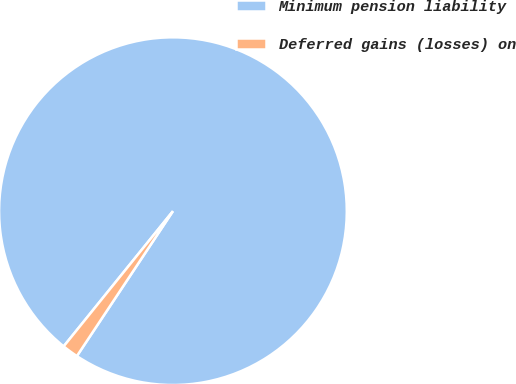Convert chart. <chart><loc_0><loc_0><loc_500><loc_500><pie_chart><fcel>Minimum pension liability<fcel>Deferred gains (losses) on<nl><fcel>98.5%<fcel>1.5%<nl></chart> 